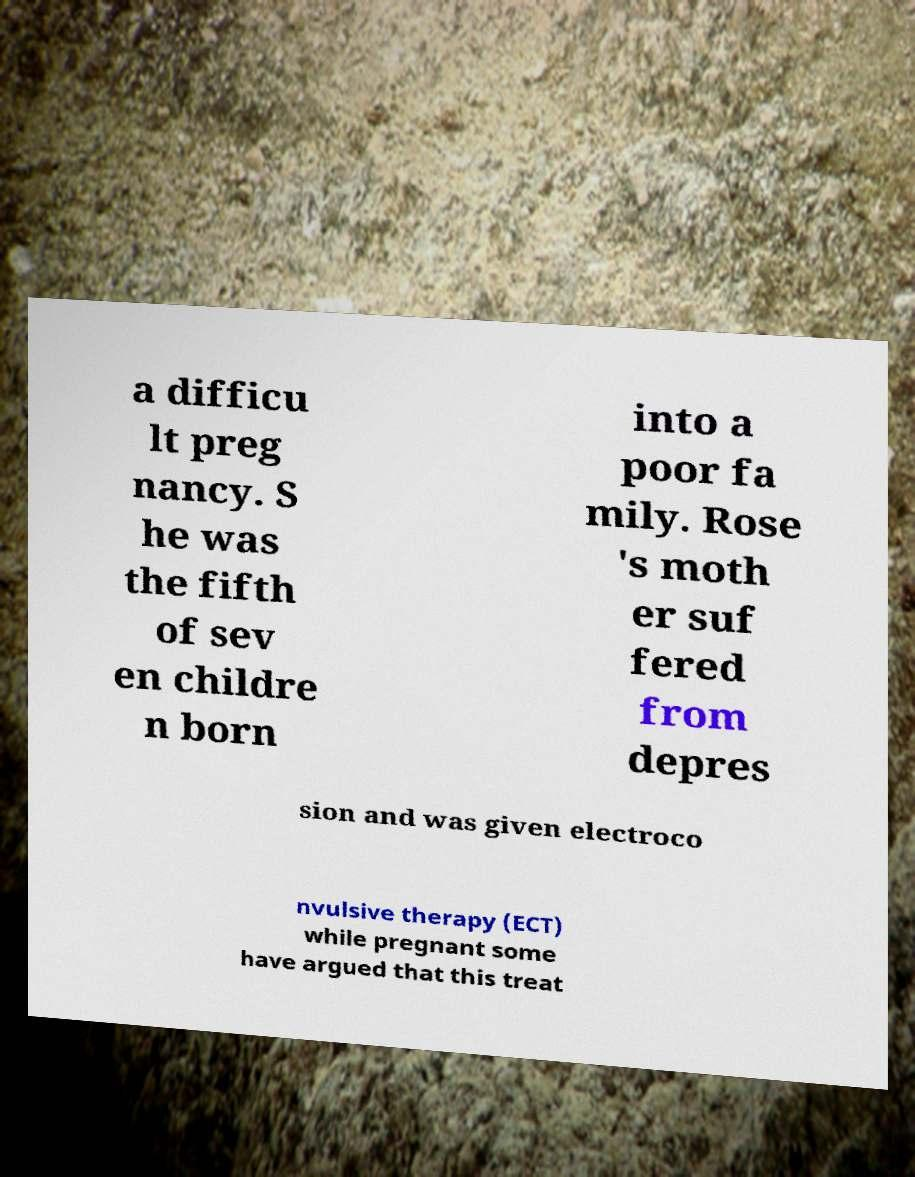For documentation purposes, I need the text within this image transcribed. Could you provide that? a difficu lt preg nancy. S he was the fifth of sev en childre n born into a poor fa mily. Rose 's moth er suf fered from depres sion and was given electroco nvulsive therapy (ECT) while pregnant some have argued that this treat 